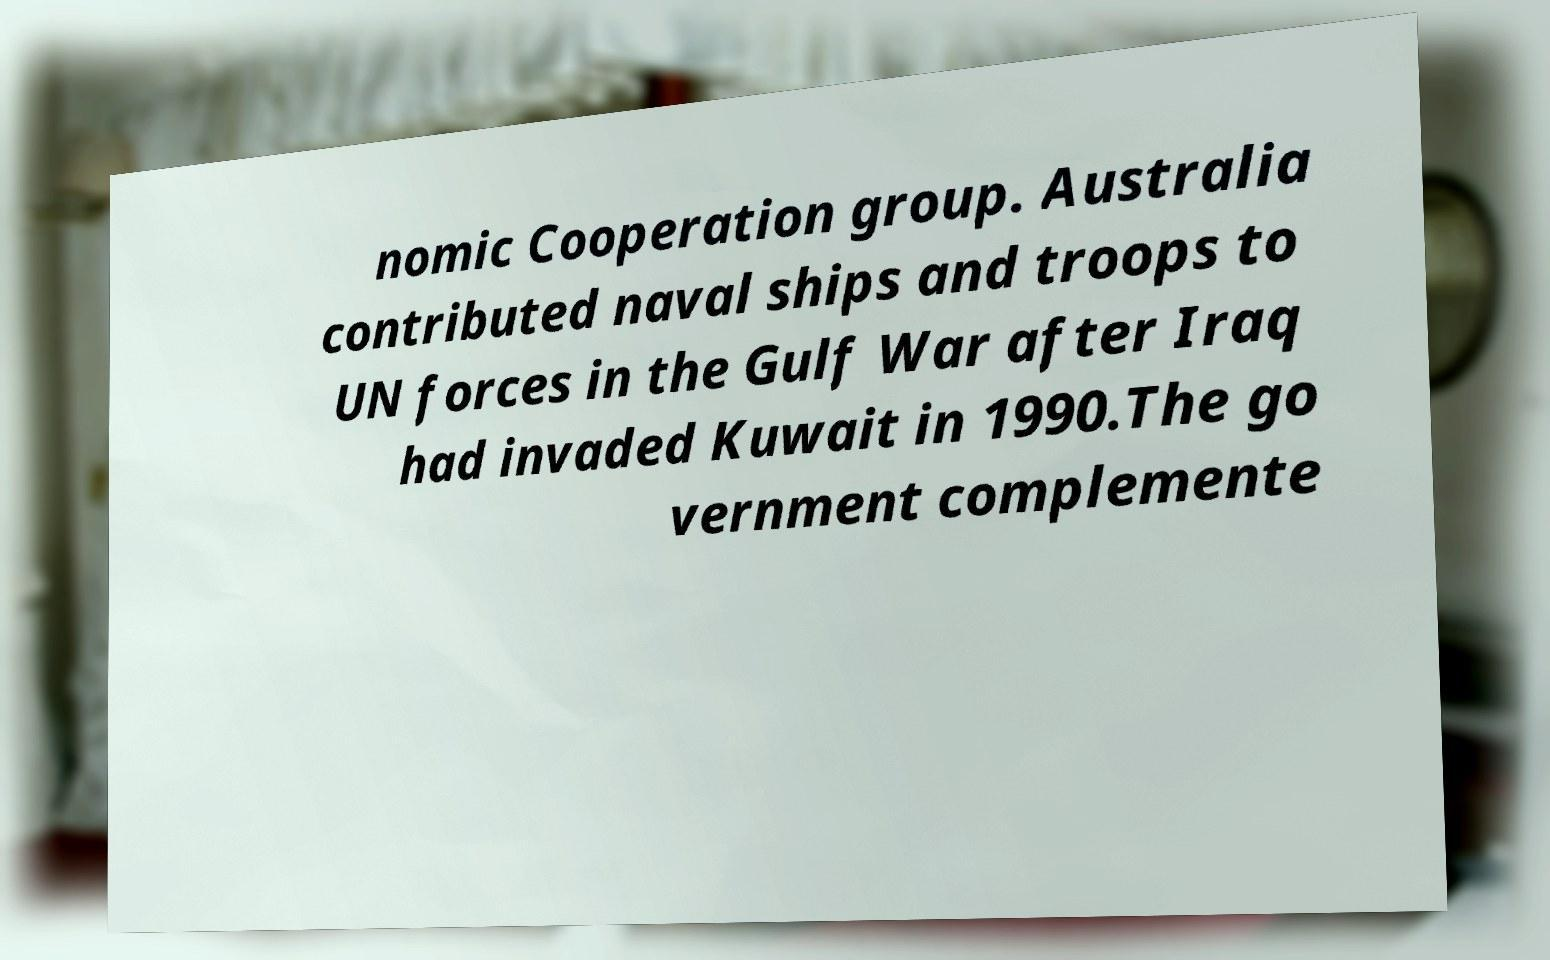What messages or text are displayed in this image? I need them in a readable, typed format. nomic Cooperation group. Australia contributed naval ships and troops to UN forces in the Gulf War after Iraq had invaded Kuwait in 1990.The go vernment complemente 